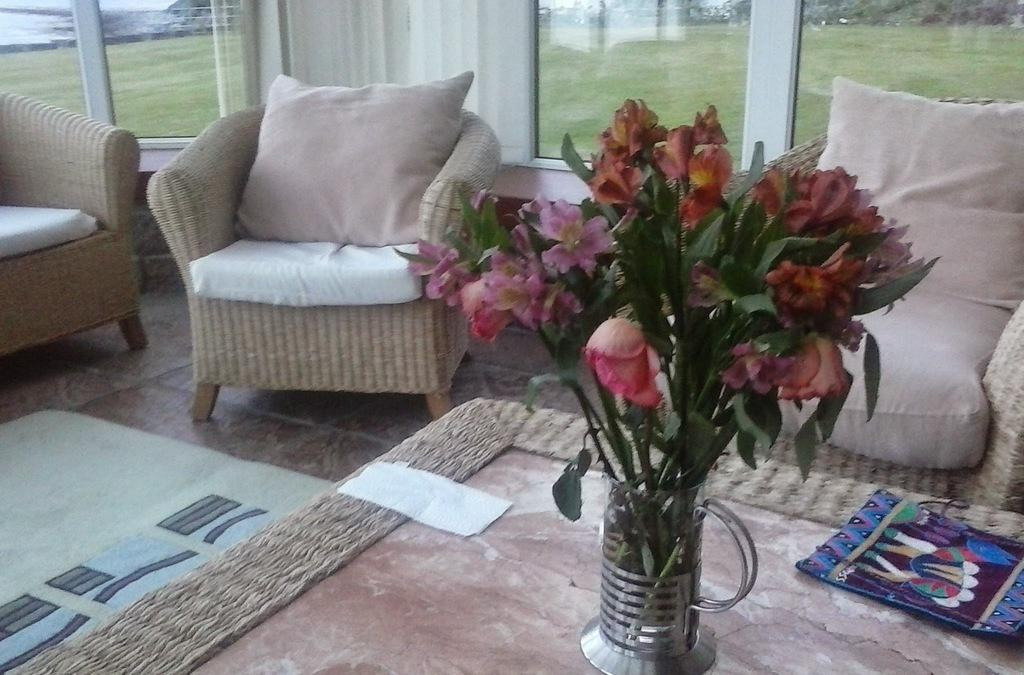What type of furniture is present in the image? There are sofa chairs in the image. What can be seen on the table in the image? There is a flower vase on a table. What architectural feature is visible in the image? There is a window in the image. What is visible outside the window? Grass is visible outside the window. What decision was made by the trees outside the window in the image? There are no trees present in the image, so no decision can be attributed to them. 